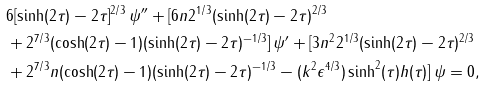Convert formula to latex. <formula><loc_0><loc_0><loc_500><loc_500>& 6 [ \sinh ( 2 \tau ) - 2 \tau ] ^ { 2 / 3 } \, \psi ^ { \prime \prime } + [ 6 n 2 ^ { 1 / 3 } ( \sinh ( 2 \tau ) - 2 \tau ) ^ { 2 / 3 } \\ & + 2 ^ { 7 / 3 } ( \cosh ( 2 \tau ) - 1 ) ( \sinh ( 2 \tau ) - 2 \tau ) ^ { - 1 / 3 } ] \, \psi ^ { \prime } + [ 3 n ^ { 2 } 2 ^ { 1 / 3 } ( \sinh ( 2 \tau ) - 2 \tau ) ^ { 2 / 3 } \\ & + 2 ^ { 7 / 3 } n ( \cosh ( 2 \tau ) - 1 ) ( \sinh ( 2 \tau ) - 2 \tau ) ^ { - 1 / 3 } - ( k ^ { 2 } \epsilon ^ { 4 / 3 } ) \sinh ^ { 2 } ( \tau ) h ( \tau ) ] \, \psi = 0 ,</formula> 